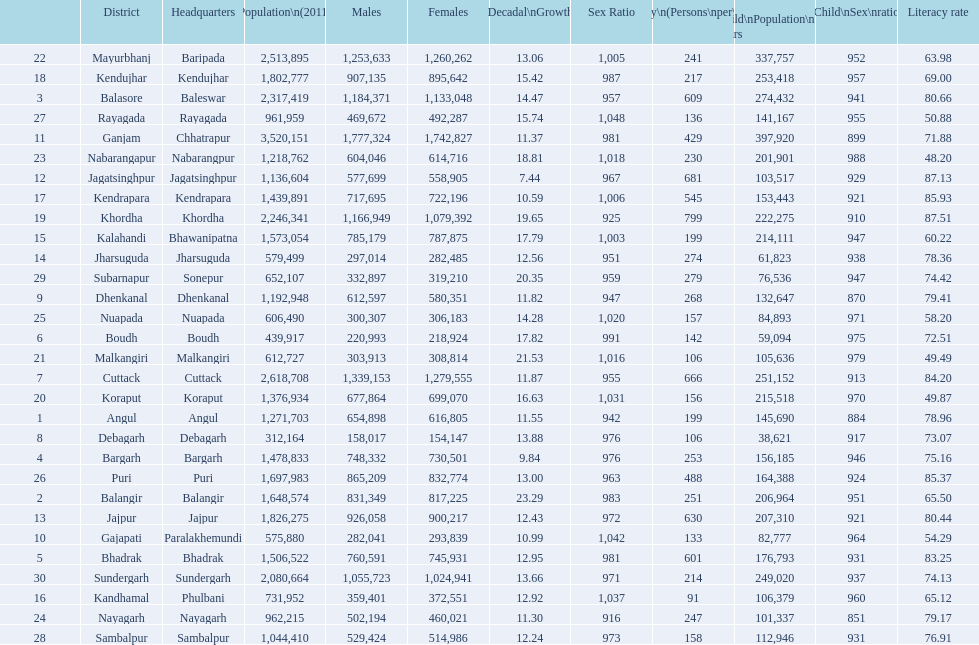Tell me a district that did not have a population over 600,000. Boudh. 